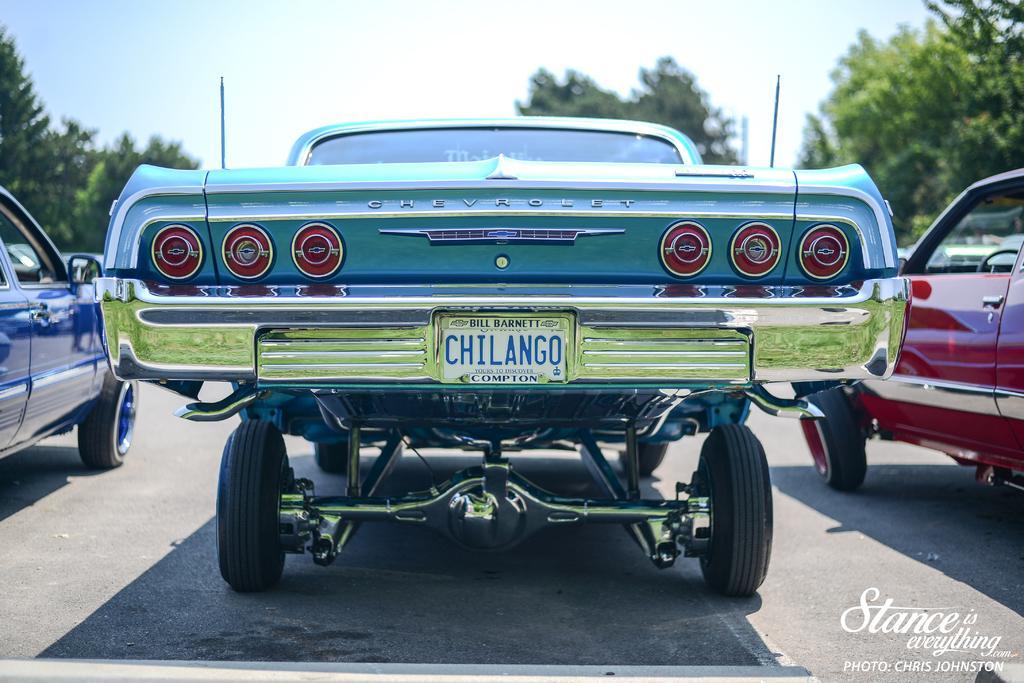In one or two sentences, can you explain what this image depicts? In this image we can see the three vehicles parked on the road. At the top there is sky and in the bottom right corner there is text. 